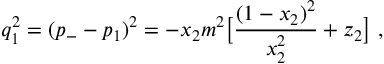Convert formula to latex. <formula><loc_0><loc_0><loc_500><loc_500>q _ { 1 } ^ { 2 } = ( p _ { - } - p _ { 1 } ) ^ { 2 } = - x _ { 2 } m ^ { 2 } \left [ \frac { ( 1 - x _ { 2 } ) ^ { 2 } } { x _ { 2 } ^ { 2 } } + z _ { 2 } \right ] \ ,</formula> 